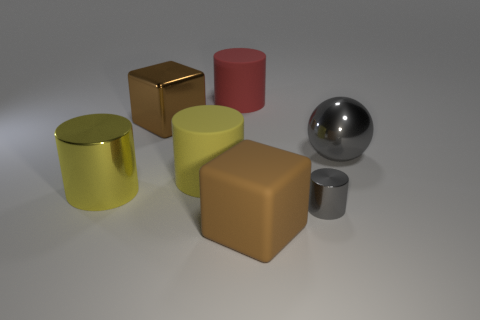Subtract all cyan cylinders. Subtract all purple cubes. How many cylinders are left? 4 Add 2 large brown matte cubes. How many objects exist? 9 Subtract all balls. How many objects are left? 6 Add 5 large shiny balls. How many large shiny balls exist? 6 Subtract 0 blue cylinders. How many objects are left? 7 Subtract all big gray metallic balls. Subtract all gray cylinders. How many objects are left? 5 Add 5 tiny objects. How many tiny objects are left? 6 